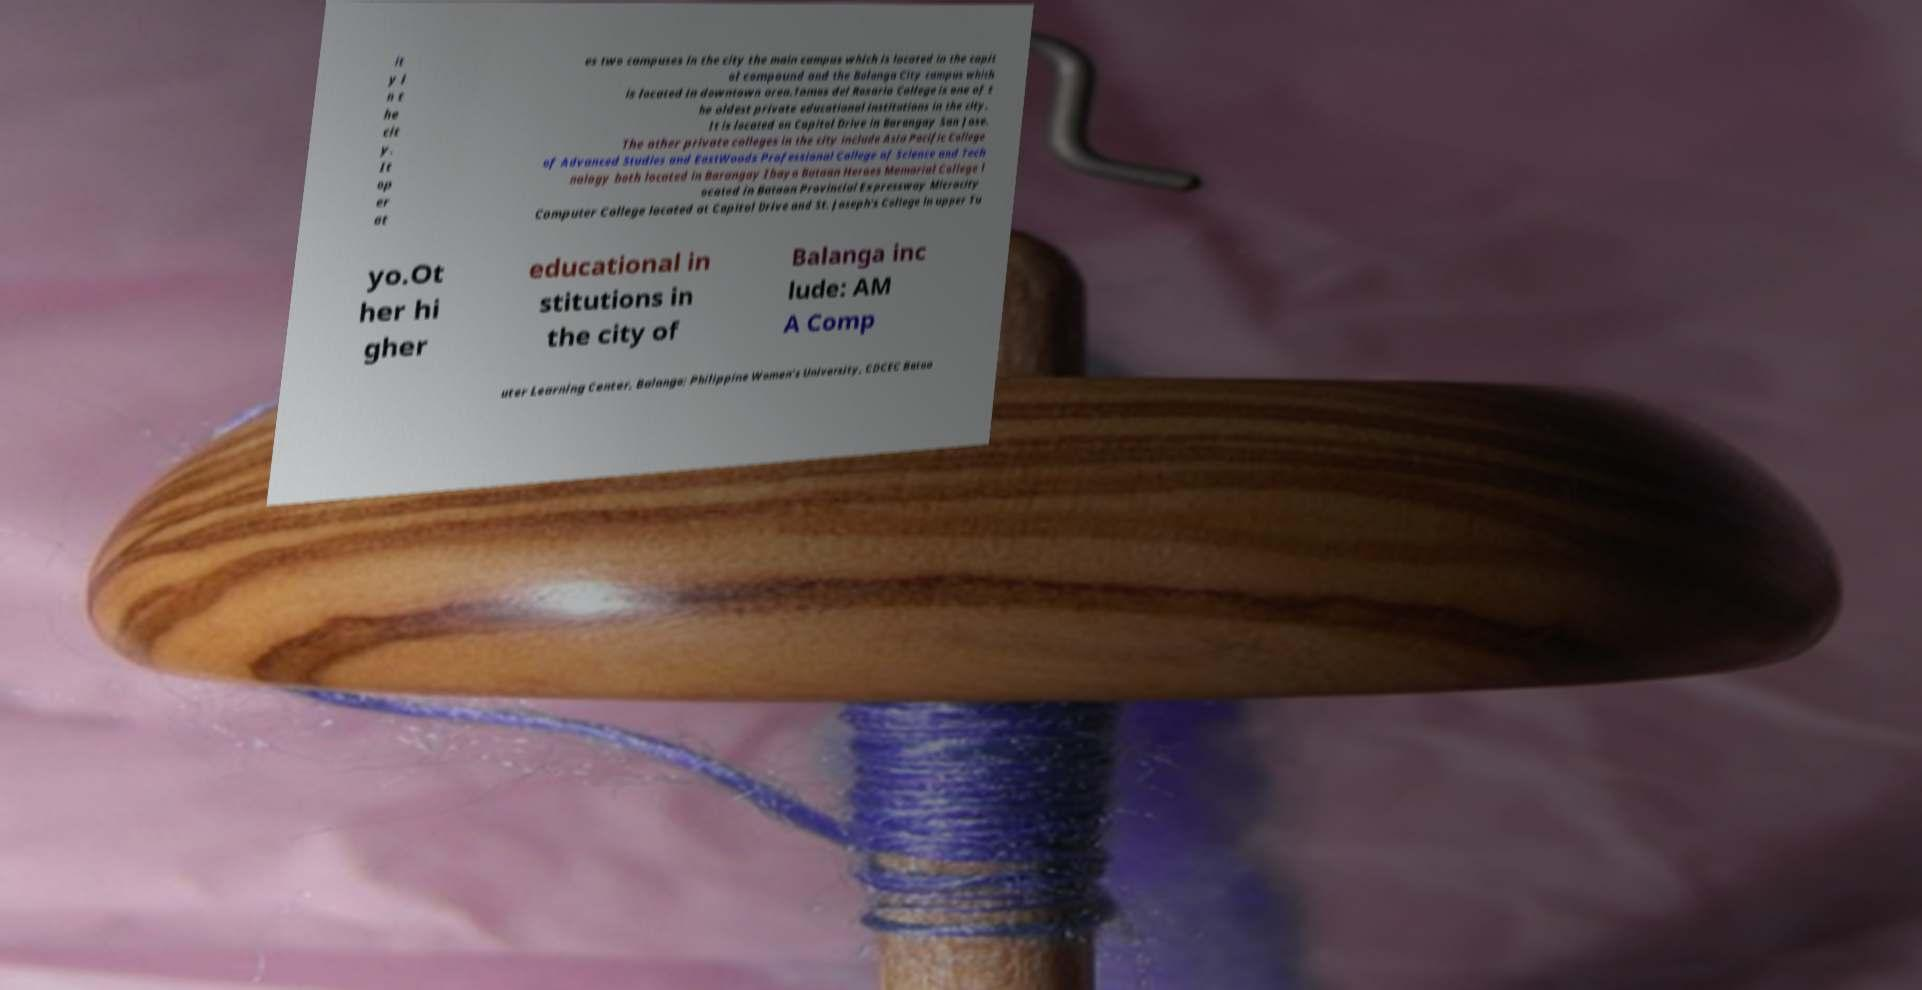For documentation purposes, I need the text within this image transcribed. Could you provide that? it y i n t he cit y. It op er at es two campuses in the city the main campus which is located in the capit ol compound and the Balanga City campus which is located in downtown area.Tomas del Rosario College is one of t he oldest private educational institutions in the city. It is located on Capitol Drive in Barangay San Jose. The other private colleges in the city include Asia Pacific College of Advanced Studies and EastWoods Professional College of Science and Tech nology both located in Barangay Ibayo Bataan Heroes Memorial College l ocated in Bataan Provincial Expressway Microcity Computer College located at Capitol Drive and St. Joseph's College in upper Tu yo.Ot her hi gher educational in stitutions in the city of Balanga inc lude: AM A Comp uter Learning Center, Balanga; Philippine Women's University, CDCEC Bataa 